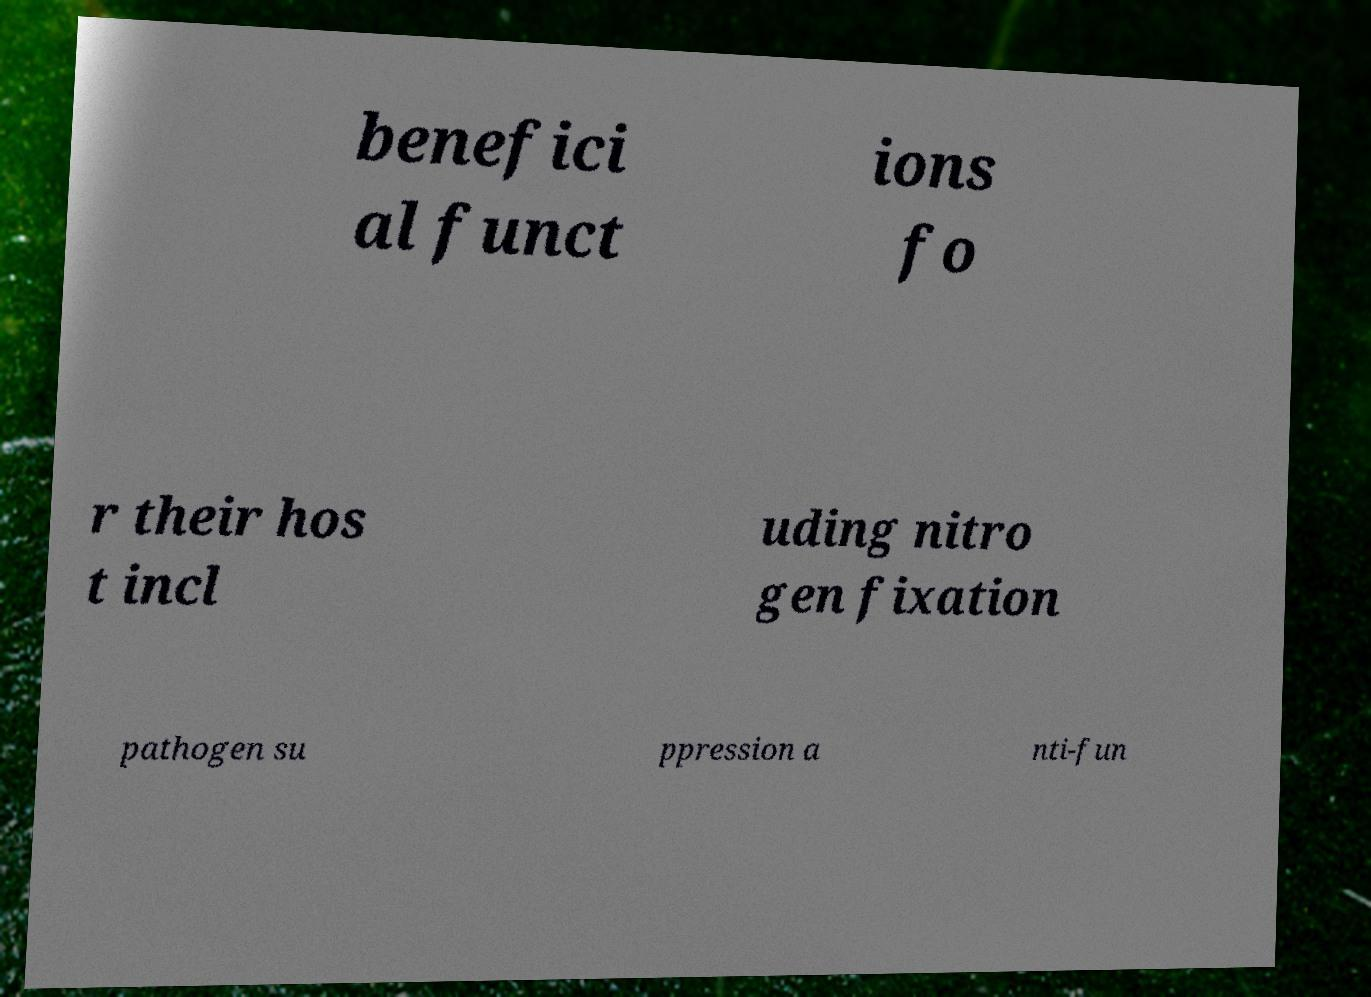For documentation purposes, I need the text within this image transcribed. Could you provide that? benefici al funct ions fo r their hos t incl uding nitro gen fixation pathogen su ppression a nti-fun 